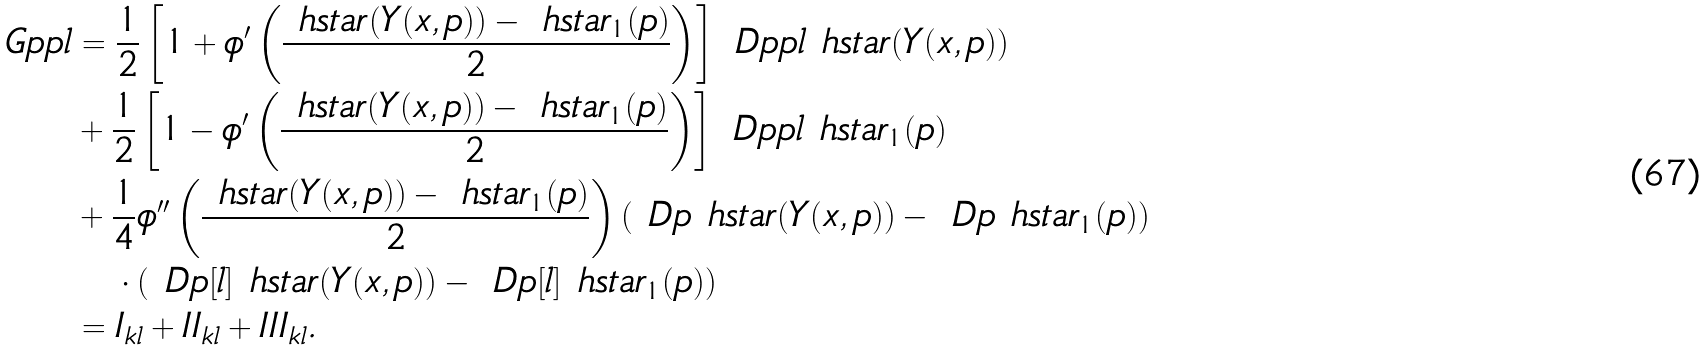<formula> <loc_0><loc_0><loc_500><loc_500>\ G p p { l } & = \frac { 1 } { 2 } \left [ 1 + \phi ^ { \prime } \left ( \frac { \ h s t a r ( Y ( x , p ) ) - \ h s t a r _ { 1 } ( p ) } { 2 } \right ) \right ] \ D p p { l } \ h s t a r ( Y ( x , p ) ) \\ & + \frac { 1 } { 2 } \left [ 1 - \phi ^ { \prime } \left ( \frac { \ h s t a r ( Y ( x , p ) ) - \ h s t a r _ { 1 } ( p ) } { 2 } \right ) \right ] \ D p p { l } \ h s t a r _ { 1 } ( p ) \\ & + \frac { 1 } { 4 } \phi ^ { \prime \prime } \left ( \frac { \ h s t a r ( Y ( x , p ) ) - \ h s t a r _ { 1 } ( p ) } { 2 } \right ) ( \ D p \ h s t a r ( Y ( x , p ) ) - \ D p \ h s t a r _ { 1 } ( p ) ) \\ & \quad \cdot ( \ D p [ l ] \ h s t a r ( Y ( x , p ) ) - \ D p [ l ] \ h s t a r _ { 1 } ( p ) ) \\ & = I _ { k l } + I I _ { k l } + I I I _ { k l } .</formula> 